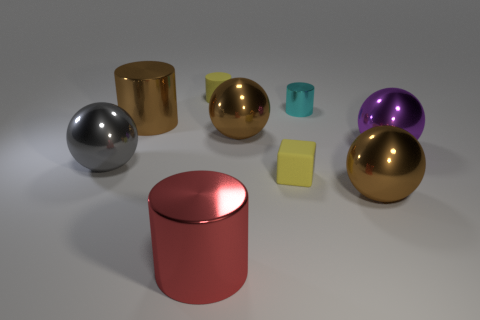Add 1 large brown cylinders. How many objects exist? 10 Subtract all metal cylinders. How many cylinders are left? 1 Subtract 1 blocks. How many blocks are left? 0 Subtract 2 brown spheres. How many objects are left? 7 Subtract all balls. How many objects are left? 5 Subtract all green spheres. Subtract all yellow blocks. How many spheres are left? 4 Subtract all purple balls. How many cyan cylinders are left? 1 Subtract all yellow matte blocks. Subtract all big gray things. How many objects are left? 7 Add 5 red cylinders. How many red cylinders are left? 6 Add 6 tiny yellow matte blocks. How many tiny yellow matte blocks exist? 7 